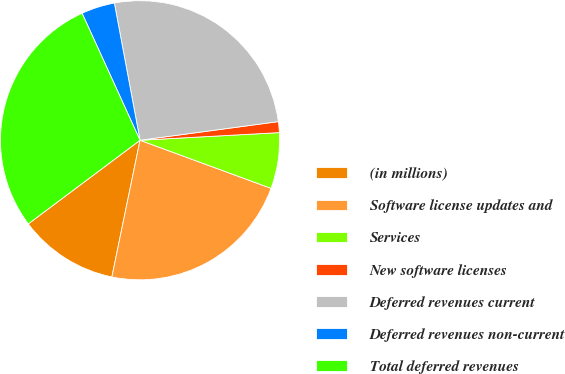Convert chart. <chart><loc_0><loc_0><loc_500><loc_500><pie_chart><fcel>(in millions)<fcel>Software license updates and<fcel>Services<fcel>New software licenses<fcel>Deferred revenues current<fcel>Deferred revenues non-current<fcel>Total deferred revenues<nl><fcel>11.54%<fcel>22.63%<fcel>6.47%<fcel>1.26%<fcel>25.81%<fcel>3.87%<fcel>28.41%<nl></chart> 